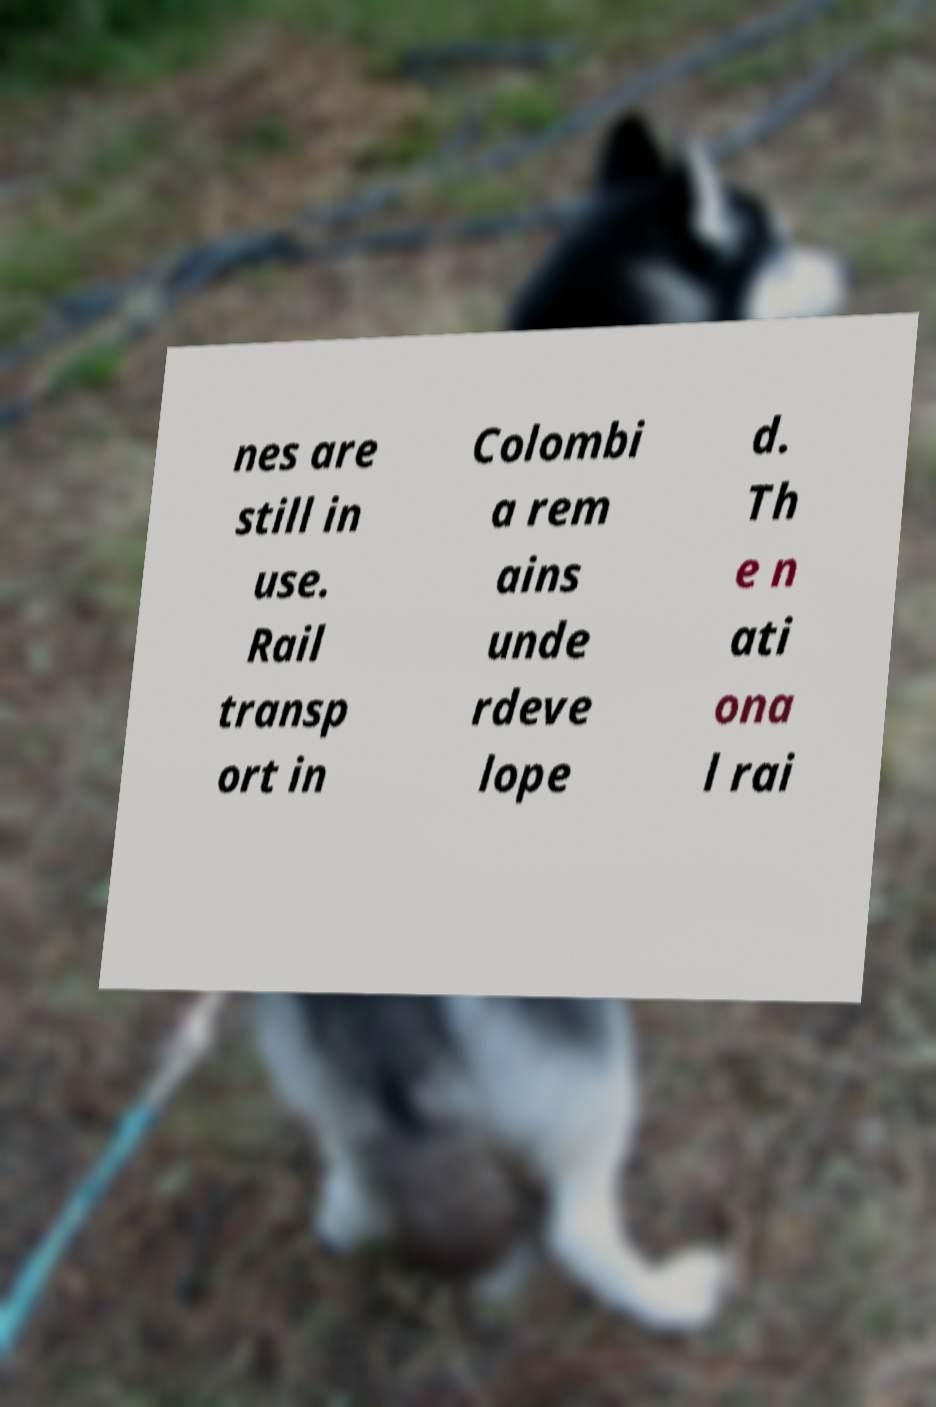Could you extract and type out the text from this image? nes are still in use. Rail transp ort in Colombi a rem ains unde rdeve lope d. Th e n ati ona l rai 